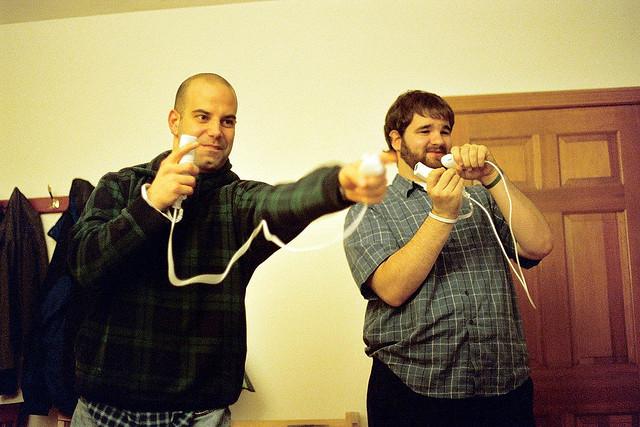Are the people playing Wii?
Keep it brief. Yes. What motion does the man on the left appear to be doing?
Be succinct. Punching. How many people?
Quick response, please. 2. 